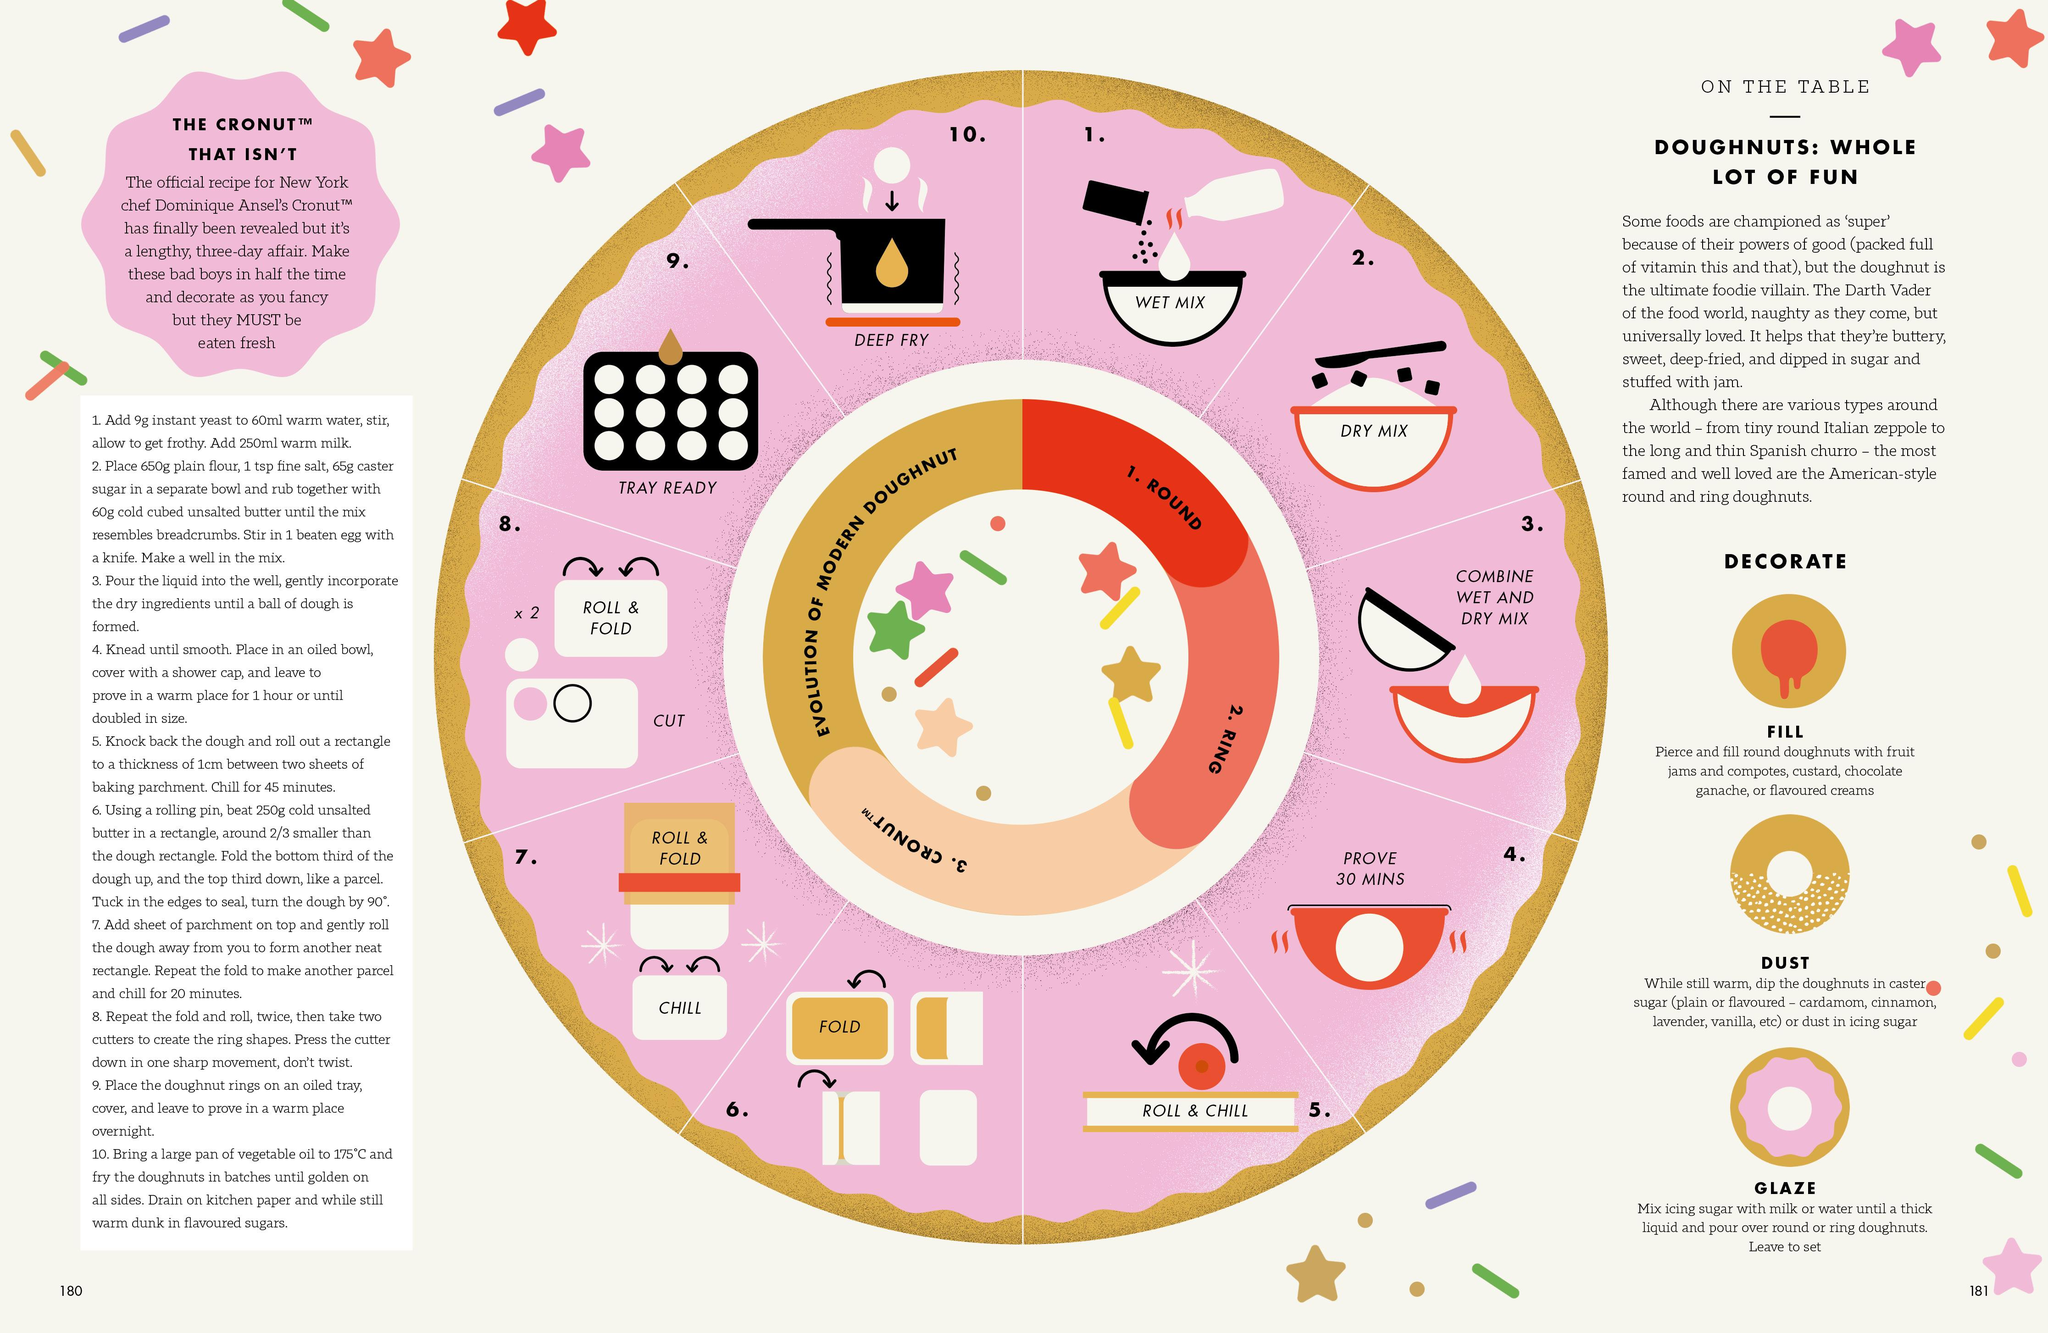Give some essential details in this illustration. The three methods of decorating a doughnut are filling, dusting, and glazing. 